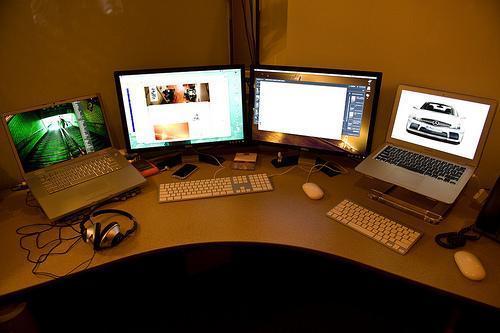How many headphones are in the picture?
Give a very brief answer. 1. How many laptops are on the desk?
Give a very brief answer. 2. 